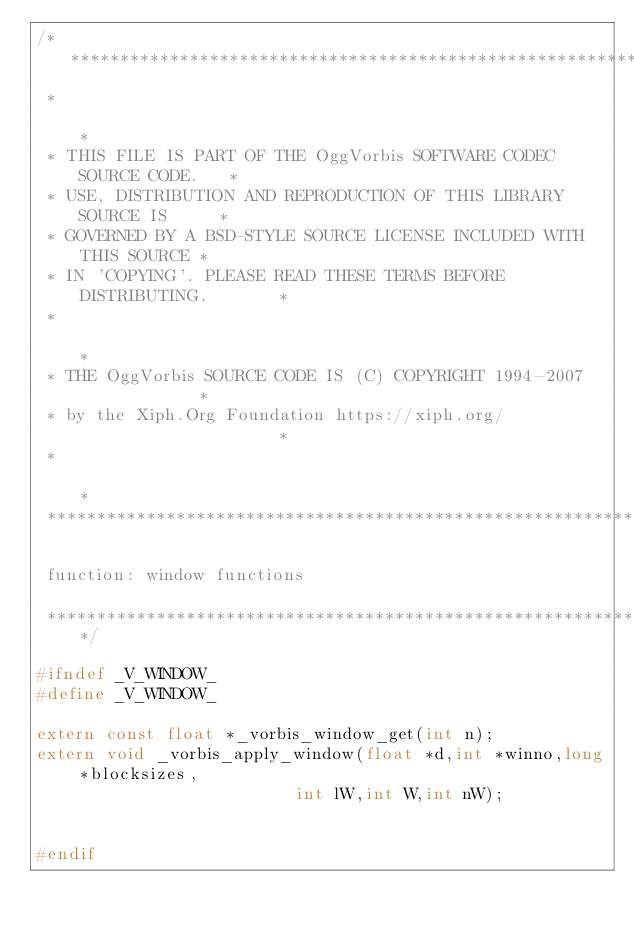Convert code to text. <code><loc_0><loc_0><loc_500><loc_500><_C_>/********************************************************************
 *                                                                  *
 * THIS FILE IS PART OF THE OggVorbis SOFTWARE CODEC SOURCE CODE.   *
 * USE, DISTRIBUTION AND REPRODUCTION OF THIS LIBRARY SOURCE IS     *
 * GOVERNED BY A BSD-STYLE SOURCE LICENSE INCLUDED WITH THIS SOURCE *
 * IN 'COPYING'. PLEASE READ THESE TERMS BEFORE DISTRIBUTING.       *
 *                                                                  *
 * THE OggVorbis SOURCE CODE IS (C) COPYRIGHT 1994-2007             *
 * by the Xiph.Org Foundation https://xiph.org/                     *
 *                                                                  *
 ********************************************************************

 function: window functions

 ********************************************************************/

#ifndef _V_WINDOW_
#define _V_WINDOW_

extern const float *_vorbis_window_get(int n);
extern void _vorbis_apply_window(float *d,int *winno,long *blocksizes,
                          int lW,int W,int nW);


#endif
</code> 